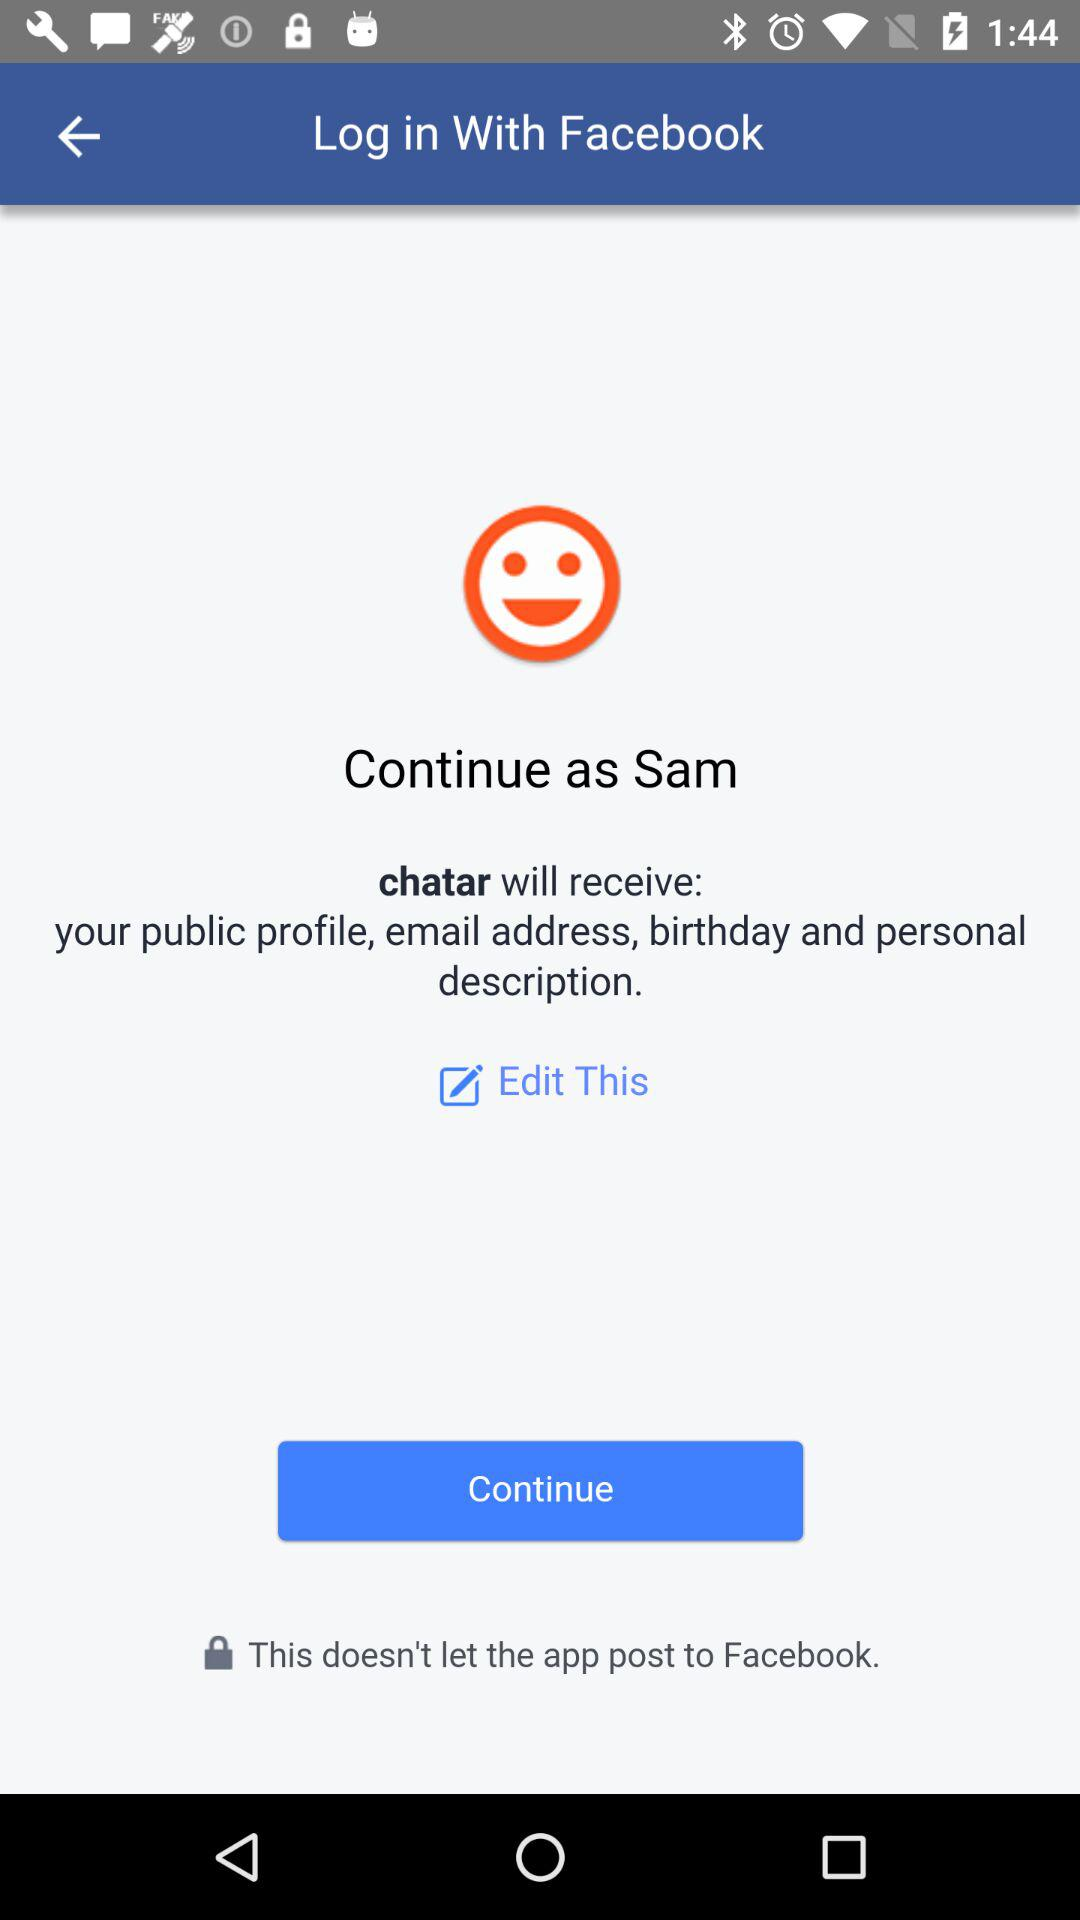What is the name of the user? The name of the user is Sam. 